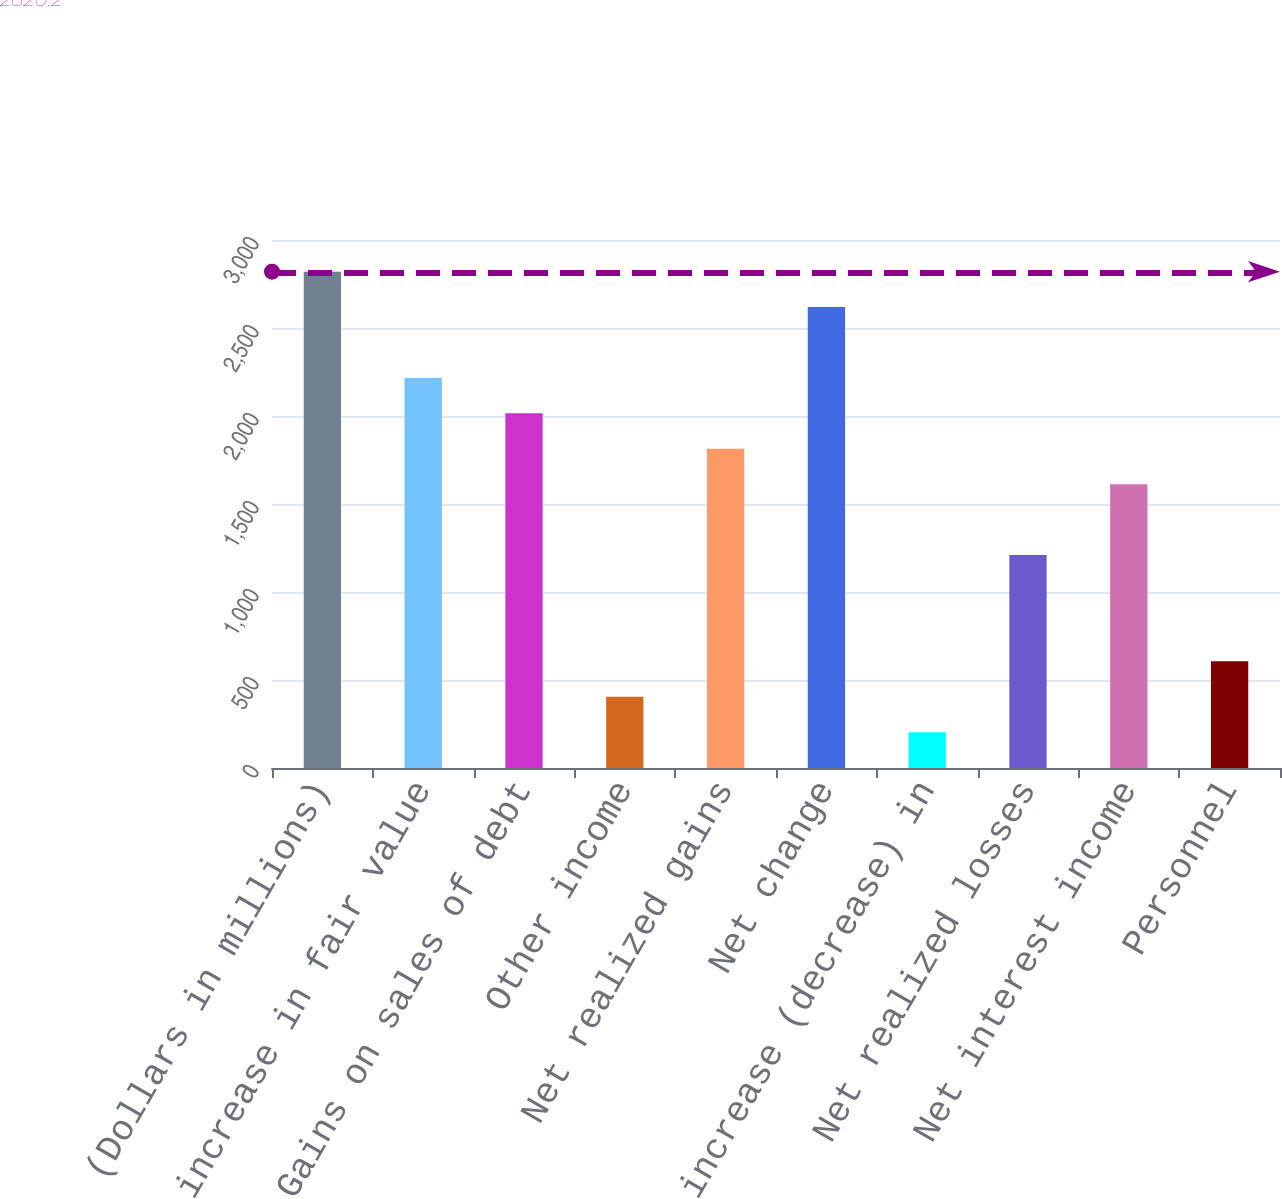Convert chart. <chart><loc_0><loc_0><loc_500><loc_500><bar_chart><fcel>(Dollars in millions)<fcel>Net increase in fair value<fcel>Gains on sales of debt<fcel>Other income<fcel>Net realized gains<fcel>Net change<fcel>Net increase (decrease) in<fcel>Net realized losses<fcel>Net interest income<fcel>Personnel<nl><fcel>2820.2<fcel>2216.3<fcel>2015<fcel>404.6<fcel>1813.7<fcel>2618.9<fcel>203.3<fcel>1209.8<fcel>1612.4<fcel>605.9<nl></chart> 